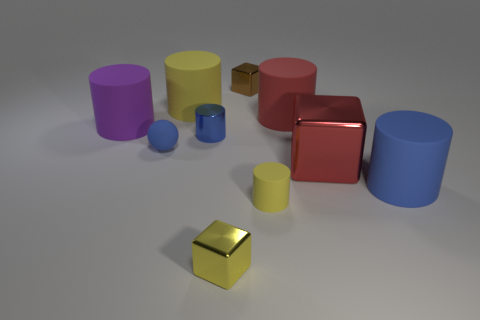Is the tiny metal cylinder the same color as the sphere?
Your answer should be compact. Yes. Does the big rubber object in front of the large purple thing have the same color as the tiny ball?
Offer a terse response. Yes. There is a yellow cylinder that is behind the yellow cylinder in front of the blue ball; what is its size?
Your answer should be compact. Large. Is there a tiny rubber ball of the same color as the small metal cylinder?
Make the answer very short. Yes. There is a object that is on the left side of the large red rubber object and right of the brown metallic thing; what shape is it?
Offer a terse response. Cylinder. Do the tiny rubber object left of the yellow cube and the tiny cylinder behind the tiny yellow cylinder have the same color?
Provide a short and direct response. Yes. What size is the other cylinder that is the same color as the tiny matte cylinder?
Offer a terse response. Large. Are there any tiny brown things that have the same material as the yellow cube?
Offer a terse response. Yes. Are there the same number of blue matte spheres that are to the left of the big purple rubber object and big yellow rubber cylinders in front of the red cube?
Ensure brevity in your answer.  Yes. There is a yellow matte thing on the right side of the brown shiny cube; what is its size?
Your response must be concise. Small. 